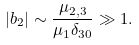<formula> <loc_0><loc_0><loc_500><loc_500>\left | b _ { 2 } \right | \sim \frac { \mu _ { 2 , 3 } } { \mu _ { 1 } \delta _ { 3 0 } } \gg 1 .</formula> 